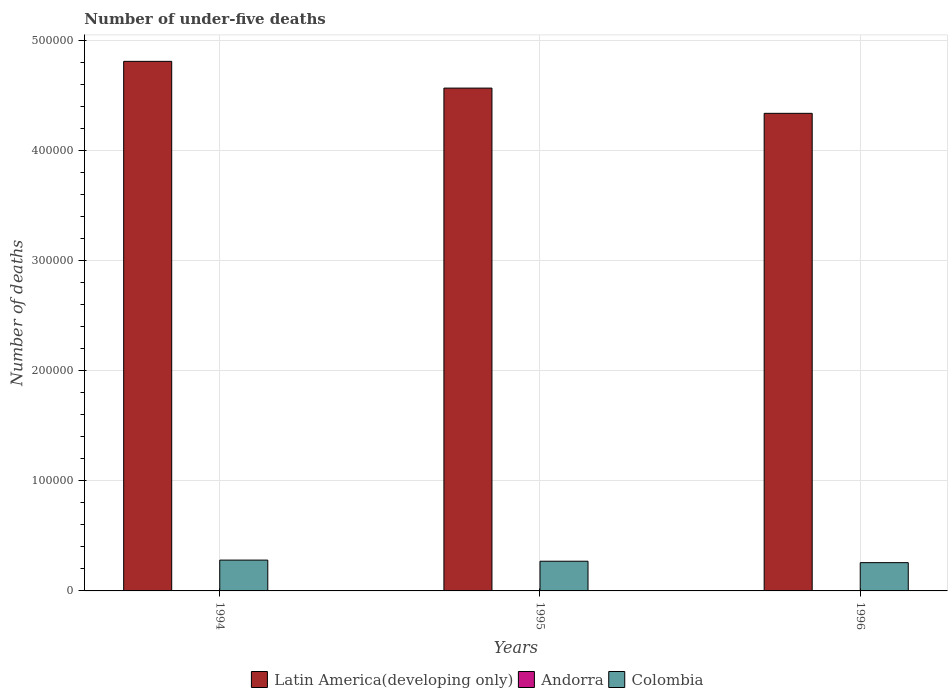Are the number of bars on each tick of the X-axis equal?
Provide a succinct answer. Yes. How many bars are there on the 2nd tick from the right?
Offer a very short reply. 3. What is the number of under-five deaths in Latin America(developing only) in 1996?
Your answer should be very brief. 4.34e+05. Across all years, what is the maximum number of under-five deaths in Andorra?
Make the answer very short. 4. Across all years, what is the minimum number of under-five deaths in Colombia?
Keep it short and to the point. 2.57e+04. In which year was the number of under-five deaths in Andorra minimum?
Your answer should be compact. 1994. What is the total number of under-five deaths in Latin America(developing only) in the graph?
Your answer should be compact. 1.37e+06. What is the difference between the number of under-five deaths in Andorra in 1994 and that in 1995?
Offer a very short reply. 0. What is the difference between the number of under-five deaths in Andorra in 1996 and the number of under-five deaths in Latin America(developing only) in 1995?
Your answer should be compact. -4.56e+05. In the year 1994, what is the difference between the number of under-five deaths in Latin America(developing only) and number of under-five deaths in Colombia?
Make the answer very short. 4.53e+05. What is the ratio of the number of under-five deaths in Latin America(developing only) in 1994 to that in 1996?
Offer a terse response. 1.11. Is the number of under-five deaths in Colombia in 1995 less than that in 1996?
Provide a succinct answer. No. What is the difference between the highest and the second highest number of under-five deaths in Andorra?
Your response must be concise. 0. In how many years, is the number of under-five deaths in Colombia greater than the average number of under-five deaths in Colombia taken over all years?
Offer a very short reply. 2. Is the sum of the number of under-five deaths in Andorra in 1994 and 1996 greater than the maximum number of under-five deaths in Colombia across all years?
Provide a succinct answer. No. What does the 1st bar from the left in 1995 represents?
Provide a succinct answer. Latin America(developing only). What does the 2nd bar from the right in 1996 represents?
Offer a very short reply. Andorra. Are all the bars in the graph horizontal?
Make the answer very short. No. How many years are there in the graph?
Keep it short and to the point. 3. What is the difference between two consecutive major ticks on the Y-axis?
Make the answer very short. 1.00e+05. Does the graph contain grids?
Your answer should be compact. Yes. What is the title of the graph?
Ensure brevity in your answer.  Number of under-five deaths. Does "India" appear as one of the legend labels in the graph?
Make the answer very short. No. What is the label or title of the Y-axis?
Your answer should be compact. Number of deaths. What is the Number of deaths of Latin America(developing only) in 1994?
Your response must be concise. 4.81e+05. What is the Number of deaths of Andorra in 1994?
Provide a short and direct response. 4. What is the Number of deaths in Colombia in 1994?
Offer a terse response. 2.80e+04. What is the Number of deaths in Latin America(developing only) in 1995?
Give a very brief answer. 4.56e+05. What is the Number of deaths in Colombia in 1995?
Offer a terse response. 2.70e+04. What is the Number of deaths of Latin America(developing only) in 1996?
Provide a succinct answer. 4.34e+05. What is the Number of deaths of Andorra in 1996?
Keep it short and to the point. 4. What is the Number of deaths in Colombia in 1996?
Ensure brevity in your answer.  2.57e+04. Across all years, what is the maximum Number of deaths of Latin America(developing only)?
Provide a short and direct response. 4.81e+05. Across all years, what is the maximum Number of deaths of Andorra?
Give a very brief answer. 4. Across all years, what is the maximum Number of deaths in Colombia?
Provide a succinct answer. 2.80e+04. Across all years, what is the minimum Number of deaths of Latin America(developing only)?
Offer a terse response. 4.34e+05. Across all years, what is the minimum Number of deaths of Andorra?
Keep it short and to the point. 4. Across all years, what is the minimum Number of deaths of Colombia?
Provide a succinct answer. 2.57e+04. What is the total Number of deaths of Latin America(developing only) in the graph?
Give a very brief answer. 1.37e+06. What is the total Number of deaths in Colombia in the graph?
Keep it short and to the point. 8.06e+04. What is the difference between the Number of deaths of Latin America(developing only) in 1994 and that in 1995?
Keep it short and to the point. 2.43e+04. What is the difference between the Number of deaths of Andorra in 1994 and that in 1995?
Provide a succinct answer. 0. What is the difference between the Number of deaths of Colombia in 1994 and that in 1995?
Provide a succinct answer. 1017. What is the difference between the Number of deaths in Latin America(developing only) in 1994 and that in 1996?
Offer a terse response. 4.72e+04. What is the difference between the Number of deaths of Colombia in 1994 and that in 1996?
Offer a very short reply. 2319. What is the difference between the Number of deaths of Latin America(developing only) in 1995 and that in 1996?
Give a very brief answer. 2.29e+04. What is the difference between the Number of deaths of Andorra in 1995 and that in 1996?
Provide a short and direct response. 0. What is the difference between the Number of deaths of Colombia in 1995 and that in 1996?
Your response must be concise. 1302. What is the difference between the Number of deaths of Latin America(developing only) in 1994 and the Number of deaths of Andorra in 1995?
Your response must be concise. 4.81e+05. What is the difference between the Number of deaths in Latin America(developing only) in 1994 and the Number of deaths in Colombia in 1995?
Your answer should be very brief. 4.54e+05. What is the difference between the Number of deaths in Andorra in 1994 and the Number of deaths in Colombia in 1995?
Your response must be concise. -2.70e+04. What is the difference between the Number of deaths of Latin America(developing only) in 1994 and the Number of deaths of Andorra in 1996?
Provide a short and direct response. 4.81e+05. What is the difference between the Number of deaths of Latin America(developing only) in 1994 and the Number of deaths of Colombia in 1996?
Your response must be concise. 4.55e+05. What is the difference between the Number of deaths in Andorra in 1994 and the Number of deaths in Colombia in 1996?
Your answer should be compact. -2.57e+04. What is the difference between the Number of deaths of Latin America(developing only) in 1995 and the Number of deaths of Andorra in 1996?
Your answer should be very brief. 4.56e+05. What is the difference between the Number of deaths of Latin America(developing only) in 1995 and the Number of deaths of Colombia in 1996?
Provide a succinct answer. 4.31e+05. What is the difference between the Number of deaths in Andorra in 1995 and the Number of deaths in Colombia in 1996?
Ensure brevity in your answer.  -2.57e+04. What is the average Number of deaths in Latin America(developing only) per year?
Provide a succinct answer. 4.57e+05. What is the average Number of deaths in Andorra per year?
Make the answer very short. 4. What is the average Number of deaths in Colombia per year?
Give a very brief answer. 2.69e+04. In the year 1994, what is the difference between the Number of deaths of Latin America(developing only) and Number of deaths of Andorra?
Ensure brevity in your answer.  4.81e+05. In the year 1994, what is the difference between the Number of deaths in Latin America(developing only) and Number of deaths in Colombia?
Provide a short and direct response. 4.53e+05. In the year 1994, what is the difference between the Number of deaths in Andorra and Number of deaths in Colombia?
Your answer should be very brief. -2.80e+04. In the year 1995, what is the difference between the Number of deaths of Latin America(developing only) and Number of deaths of Andorra?
Keep it short and to the point. 4.56e+05. In the year 1995, what is the difference between the Number of deaths of Latin America(developing only) and Number of deaths of Colombia?
Make the answer very short. 4.30e+05. In the year 1995, what is the difference between the Number of deaths of Andorra and Number of deaths of Colombia?
Your answer should be very brief. -2.70e+04. In the year 1996, what is the difference between the Number of deaths of Latin America(developing only) and Number of deaths of Andorra?
Offer a very short reply. 4.34e+05. In the year 1996, what is the difference between the Number of deaths of Latin America(developing only) and Number of deaths of Colombia?
Give a very brief answer. 4.08e+05. In the year 1996, what is the difference between the Number of deaths in Andorra and Number of deaths in Colombia?
Ensure brevity in your answer.  -2.57e+04. What is the ratio of the Number of deaths of Latin America(developing only) in 1994 to that in 1995?
Your answer should be compact. 1.05. What is the ratio of the Number of deaths of Andorra in 1994 to that in 1995?
Offer a terse response. 1. What is the ratio of the Number of deaths in Colombia in 1994 to that in 1995?
Provide a short and direct response. 1.04. What is the ratio of the Number of deaths of Latin America(developing only) in 1994 to that in 1996?
Provide a short and direct response. 1.11. What is the ratio of the Number of deaths of Andorra in 1994 to that in 1996?
Your answer should be very brief. 1. What is the ratio of the Number of deaths of Colombia in 1994 to that in 1996?
Make the answer very short. 1.09. What is the ratio of the Number of deaths in Latin America(developing only) in 1995 to that in 1996?
Make the answer very short. 1.05. What is the ratio of the Number of deaths of Colombia in 1995 to that in 1996?
Offer a terse response. 1.05. What is the difference between the highest and the second highest Number of deaths in Latin America(developing only)?
Offer a very short reply. 2.43e+04. What is the difference between the highest and the second highest Number of deaths of Colombia?
Keep it short and to the point. 1017. What is the difference between the highest and the lowest Number of deaths in Latin America(developing only)?
Your answer should be very brief. 4.72e+04. What is the difference between the highest and the lowest Number of deaths of Andorra?
Your answer should be very brief. 0. What is the difference between the highest and the lowest Number of deaths in Colombia?
Your answer should be compact. 2319. 